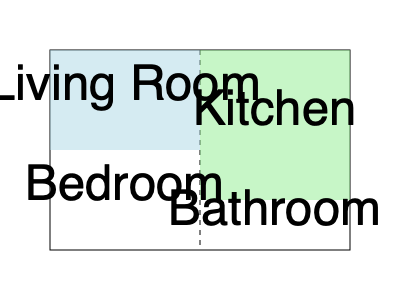Based on the given 2D floor plan, which room would have the highest ceiling if the roof slopes upward from left to right? To determine which room would have the highest ceiling, we need to analyze the floor plan and visualize it in 3D space:

1. The floor plan shows a rectangular house divided into four rooms.
2. We're told that the roof slopes upward from left to right.
3. The left side of the house contains the Living Room and Bedroom.
4. The right side of the house contains the Kitchen and Bathroom.
5. Since the roof slopes upward from left to right, the rooms on the right side will have higher ceilings than those on the left.
6. Between the Kitchen and Bathroom on the right side, the Kitchen is positioned higher (more towards the top of the floor plan).
7. In a sloping roof scenario, rooms positioned higher on the floor plan will have more vertical space.

Therefore, the Kitchen, being on the right side and positioned higher than the Bathroom, would have the highest ceiling in this 3D visualization.
Answer: Kitchen 